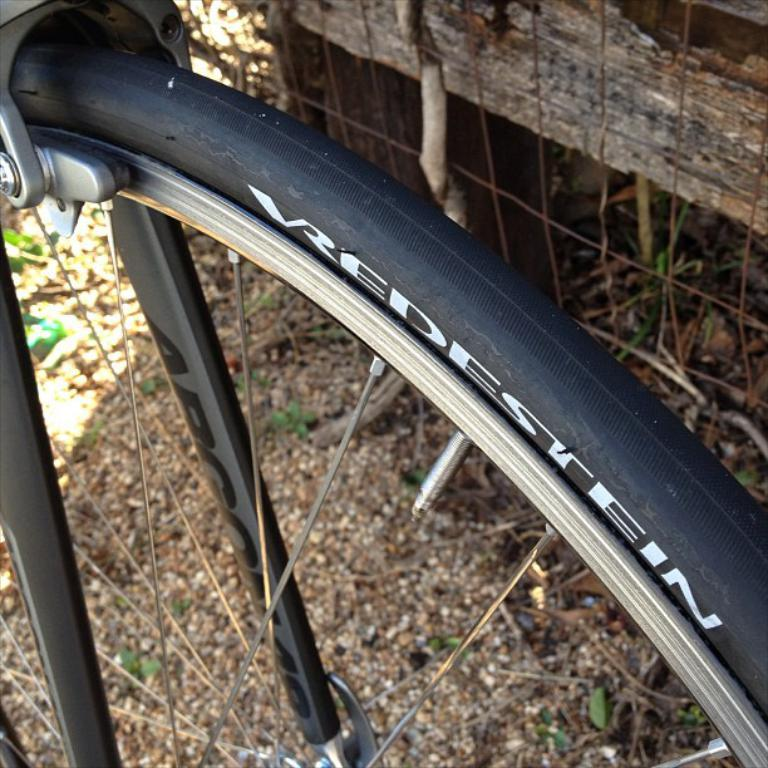What is the main subject of the image? The main subject of the image is a bicycle tire and rim. What are the spokes used for in the image? The spokes are associated with the bicycle tire and rim, providing support and structure. What can be seen in the background of the image? There is fencing in the image. How many horses are visible in the image? There are no horses present in the image; it features a bicycle tire and rim with spokes and fencing in the background. 